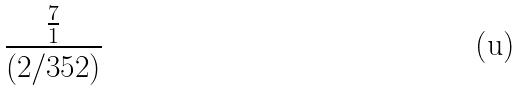Convert formula to latex. <formula><loc_0><loc_0><loc_500><loc_500>\frac { \frac { 7 } { 1 } } { ( 2 / 3 5 2 ) }</formula> 